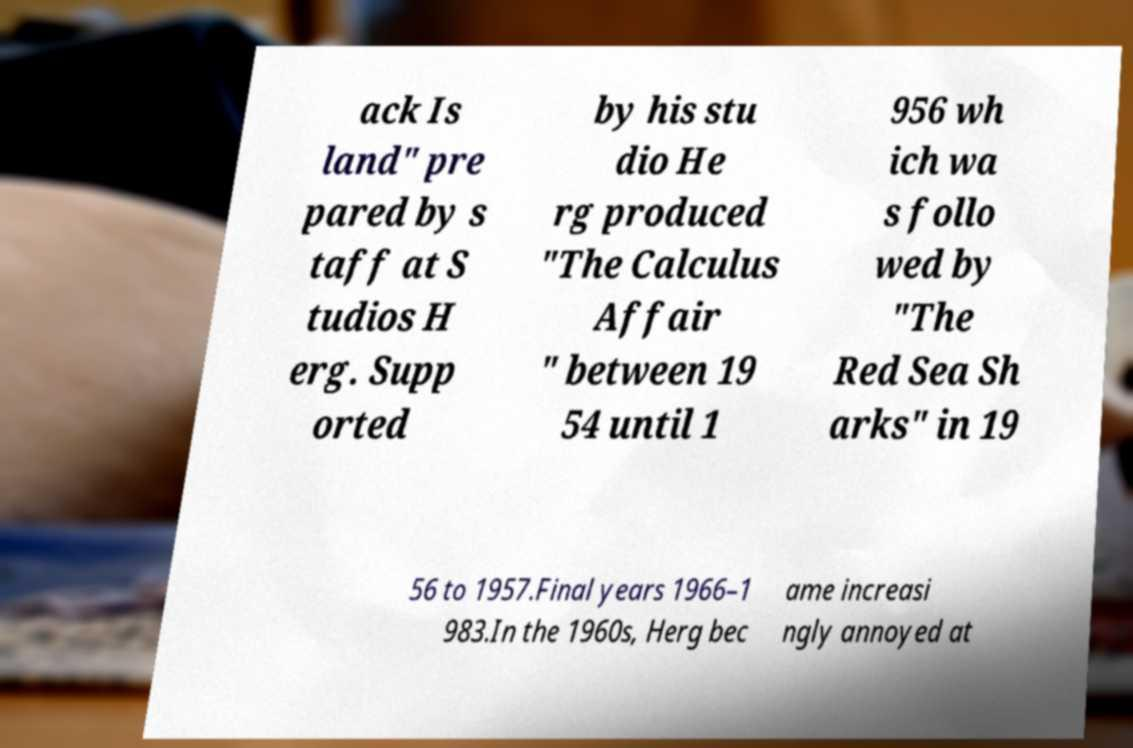Can you read and provide the text displayed in the image?This photo seems to have some interesting text. Can you extract and type it out for me? ack Is land" pre pared by s taff at S tudios H erg. Supp orted by his stu dio He rg produced "The Calculus Affair " between 19 54 until 1 956 wh ich wa s follo wed by "The Red Sea Sh arks" in 19 56 to 1957.Final years 1966–1 983.In the 1960s, Herg bec ame increasi ngly annoyed at 